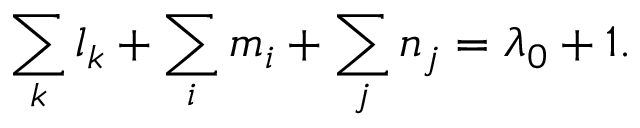Convert formula to latex. <formula><loc_0><loc_0><loc_500><loc_500>\sum _ { k } l _ { k } + \sum _ { i } m _ { i } + \sum _ { j } n _ { j } = \lambda _ { 0 } + 1 .</formula> 